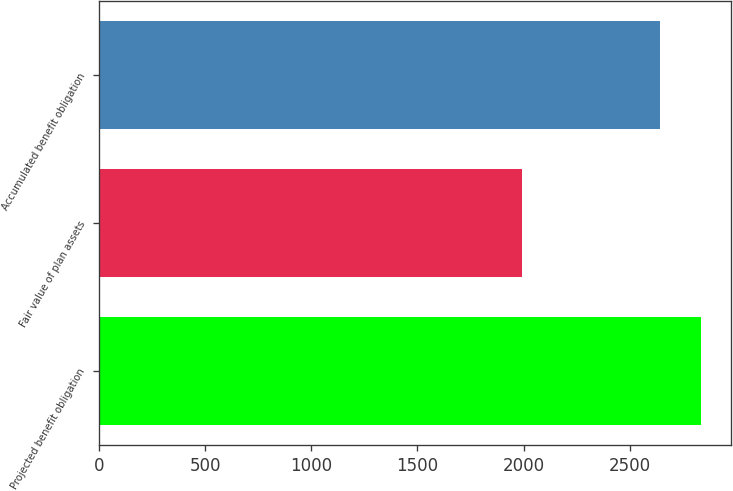<chart> <loc_0><loc_0><loc_500><loc_500><bar_chart><fcel>Projected benefit obligation<fcel>Fair value of plan assets<fcel>Accumulated benefit obligation<nl><fcel>2834<fcel>1992<fcel>2641<nl></chart> 